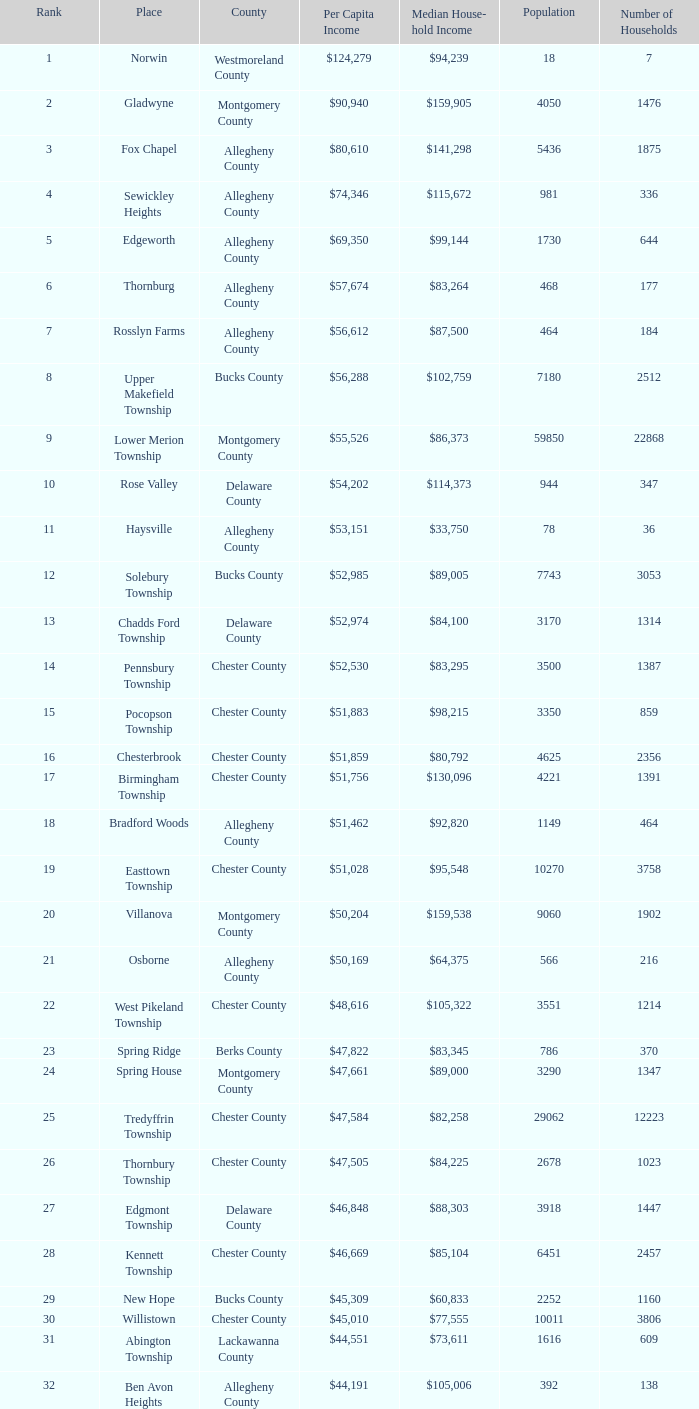What is the average individual income in fayette county? $42,131. 